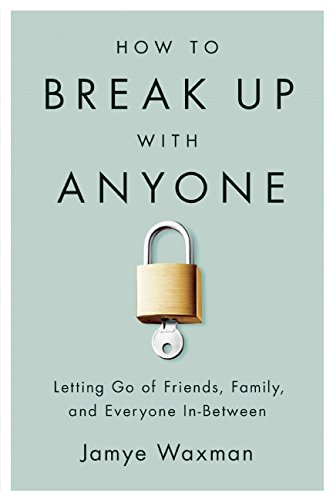What emotions might one feel after reading this book? Readers might feel a sense of empowerment and relief after reading this book, as it provides practical advice for gracefully ending relationships that no longer serve their well-being. 